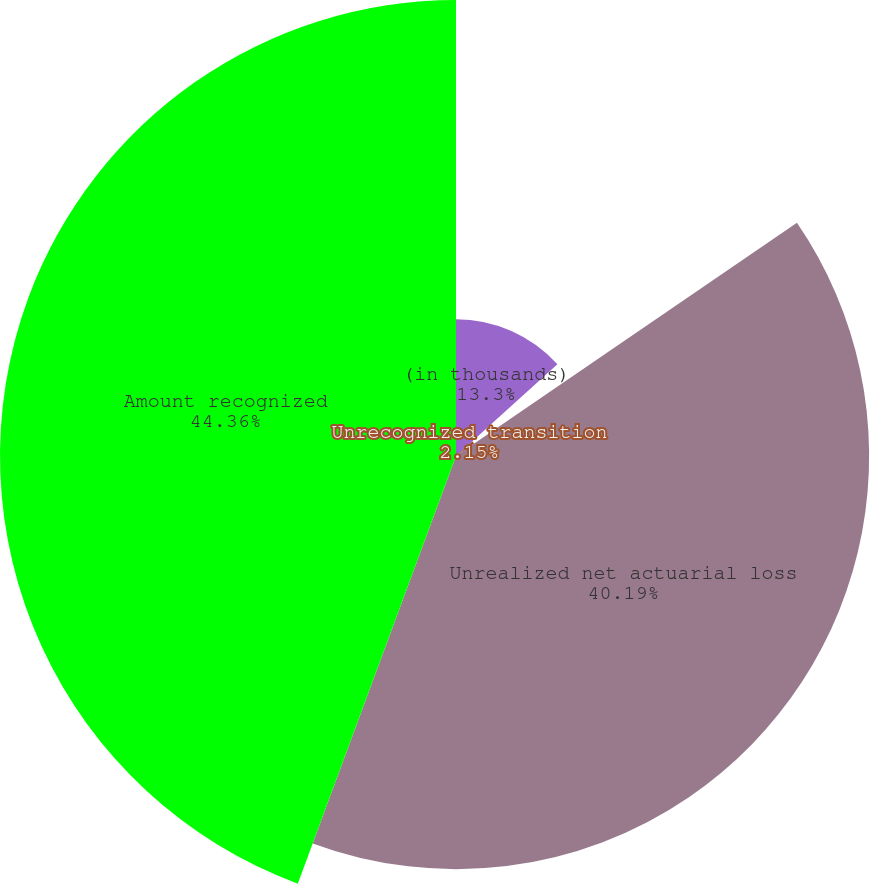Convert chart to OTSL. <chart><loc_0><loc_0><loc_500><loc_500><pie_chart><fcel>(in thousands)<fcel>Unrecognized transition<fcel>Unrealized net actuarial loss<fcel>Amount recognized<nl><fcel>13.3%<fcel>2.15%<fcel>40.19%<fcel>44.36%<nl></chart> 